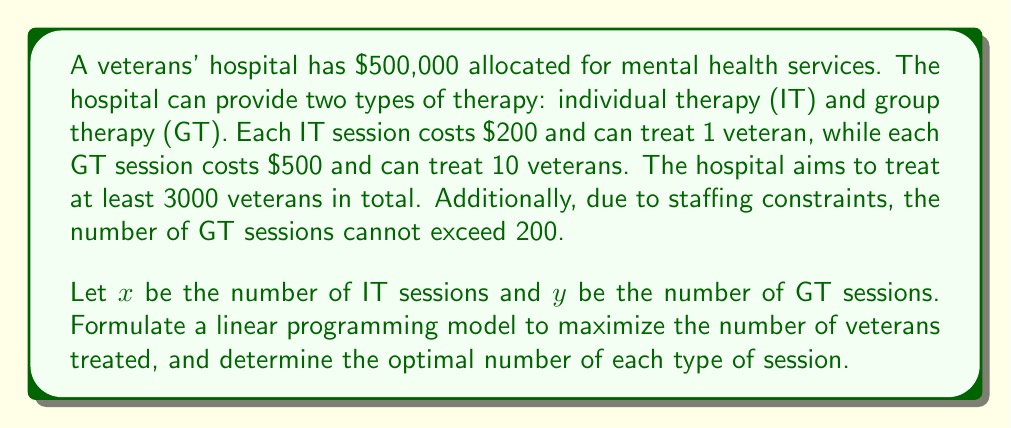Could you help me with this problem? To solve this problem, we'll follow these steps:

1. Define the objective function
2. Identify the constraints
3. Set up the linear programming model
4. Solve the model using the graphical method

Step 1: Define the objective function

The objective is to maximize the number of veterans treated. Each IT session treats 1 veteran, and each GT session treats 10 veterans.

Objective function: Maximize $Z = x + 10y$

Step 2: Identify the constraints

a) Budget constraint: $200x + 500y \leq 500000$
b) Minimum treatment requirement: $x + 10y \geq 3000$
c) Group therapy session limit: $y \leq 200$
d) Non-negativity constraints: $x \geq 0, y \geq 0$

Step 3: Set up the linear programming model

Maximize $Z = x + 10y$
Subject to:
$$\begin{align*}
200x + 500y &\leq 500000 \\
x + 10y &\geq 3000 \\
y &\leq 200 \\
x, y &\geq 0
\end{align*}$$

Step 4: Solve the model using the graphical method

a) Plot the constraints:
   - $200x + 500y = 500000$ simplifies to $y = 1000 - 0.4x$
   - $x + 10y = 3000$ simplifies to $y = 300 - 0.1x$
   - $y = 200$

b) Identify the feasible region

c) Find the corner points of the feasible region:
   - (0, 200)
   - (500, 200)
   - (2000, 100)
   - (3000, 0)

d) Evaluate the objective function at each corner point:
   - (0, 200): $Z = 0 + 10(200) = 2000$
   - (500, 200): $Z = 500 + 10(200) = 2500$
   - (2000, 100): $Z = 2000 + 10(100) = 3000$
   - (3000, 0): $Z = 3000 + 10(0) = 3000$

The maximum value of Z occurs at the point (2000, 100).
Answer: The optimal solution is to provide 2000 individual therapy sessions and 100 group therapy sessions, treating a total of 3000 veterans. 